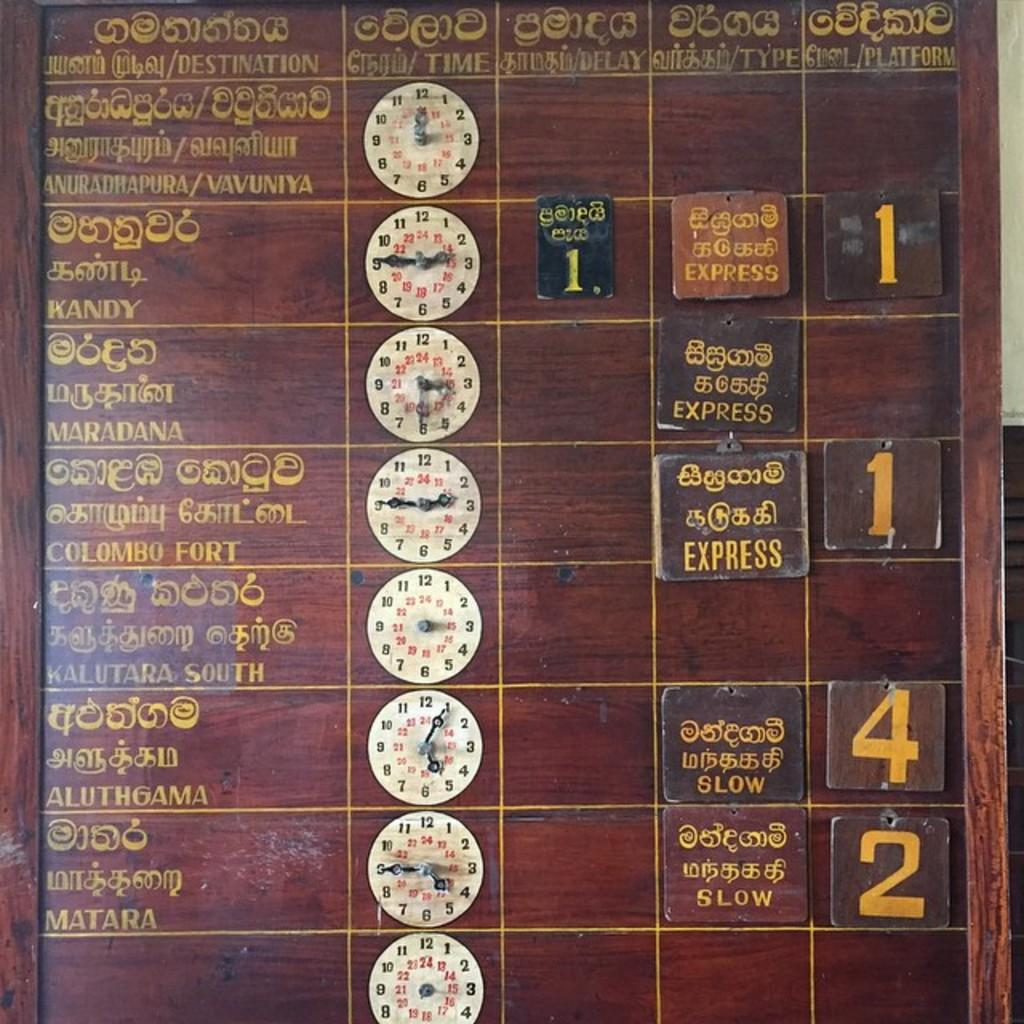<image>
Create a compact narrative representing the image presented. a wooden board with number blocks displaying 1, 2 and 4 